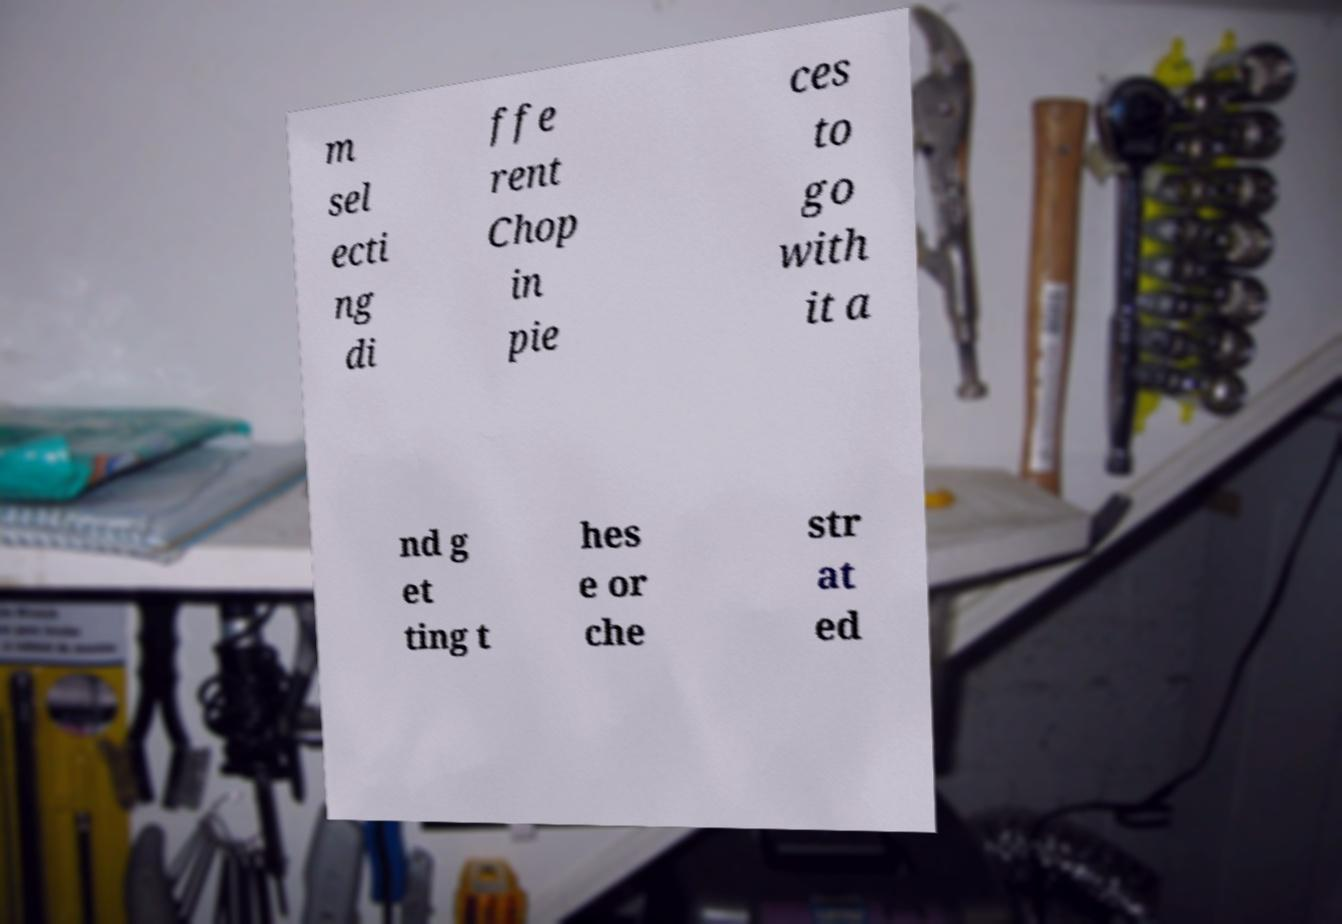Please read and relay the text visible in this image. What does it say? m sel ecti ng di ffe rent Chop in pie ces to go with it a nd g et ting t hes e or che str at ed 